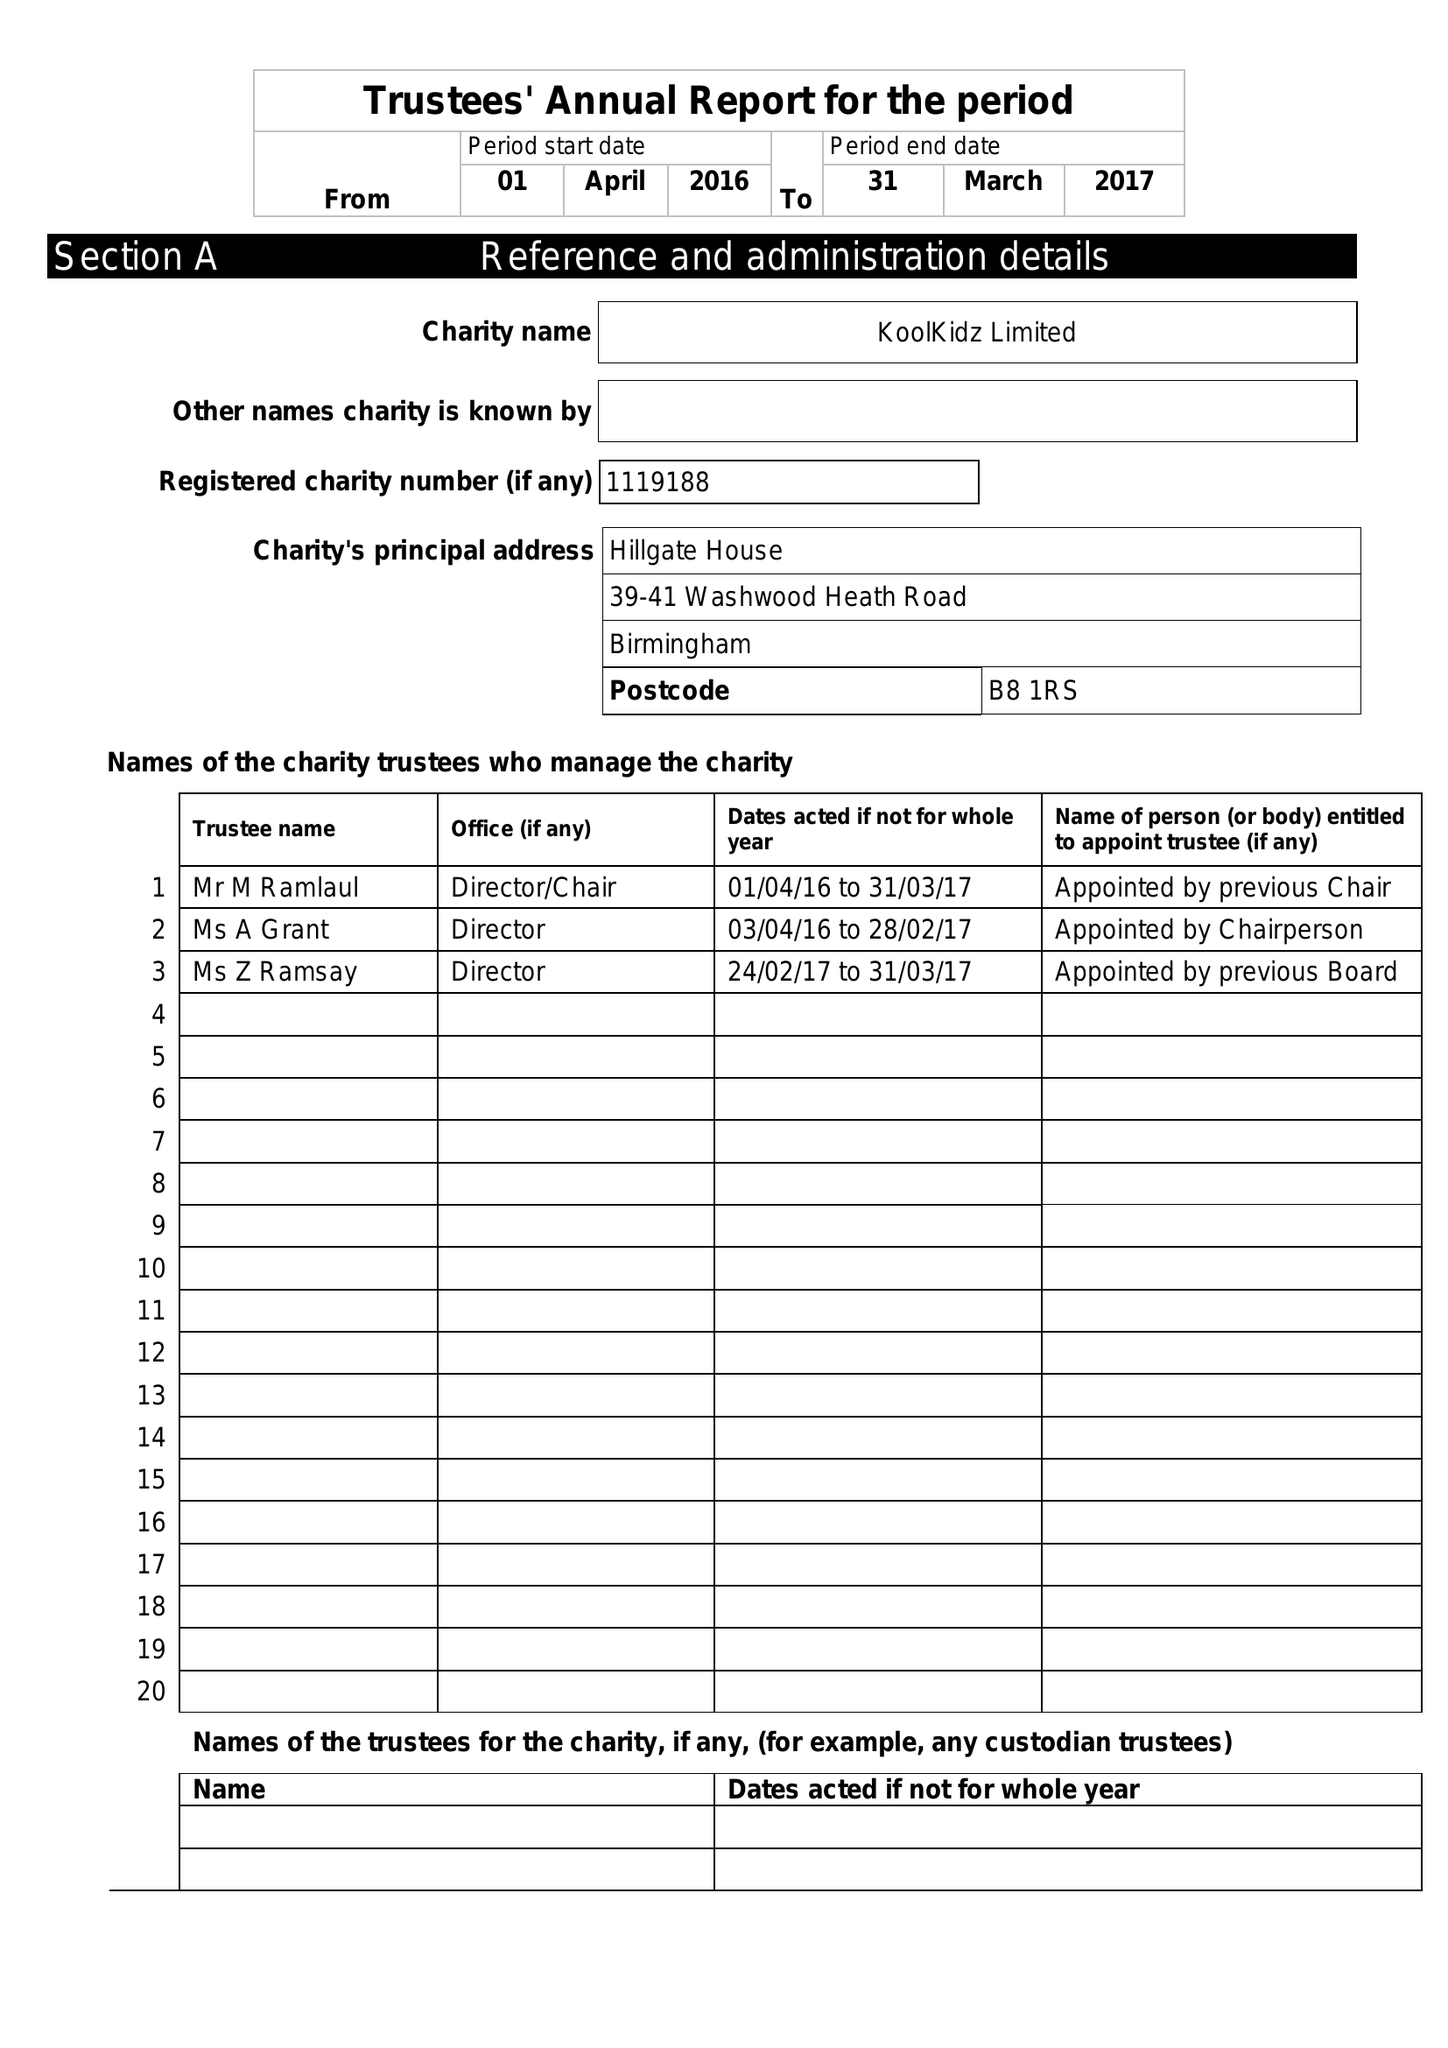What is the value for the address__postcode?
Answer the question using a single word or phrase. B8 1RS 